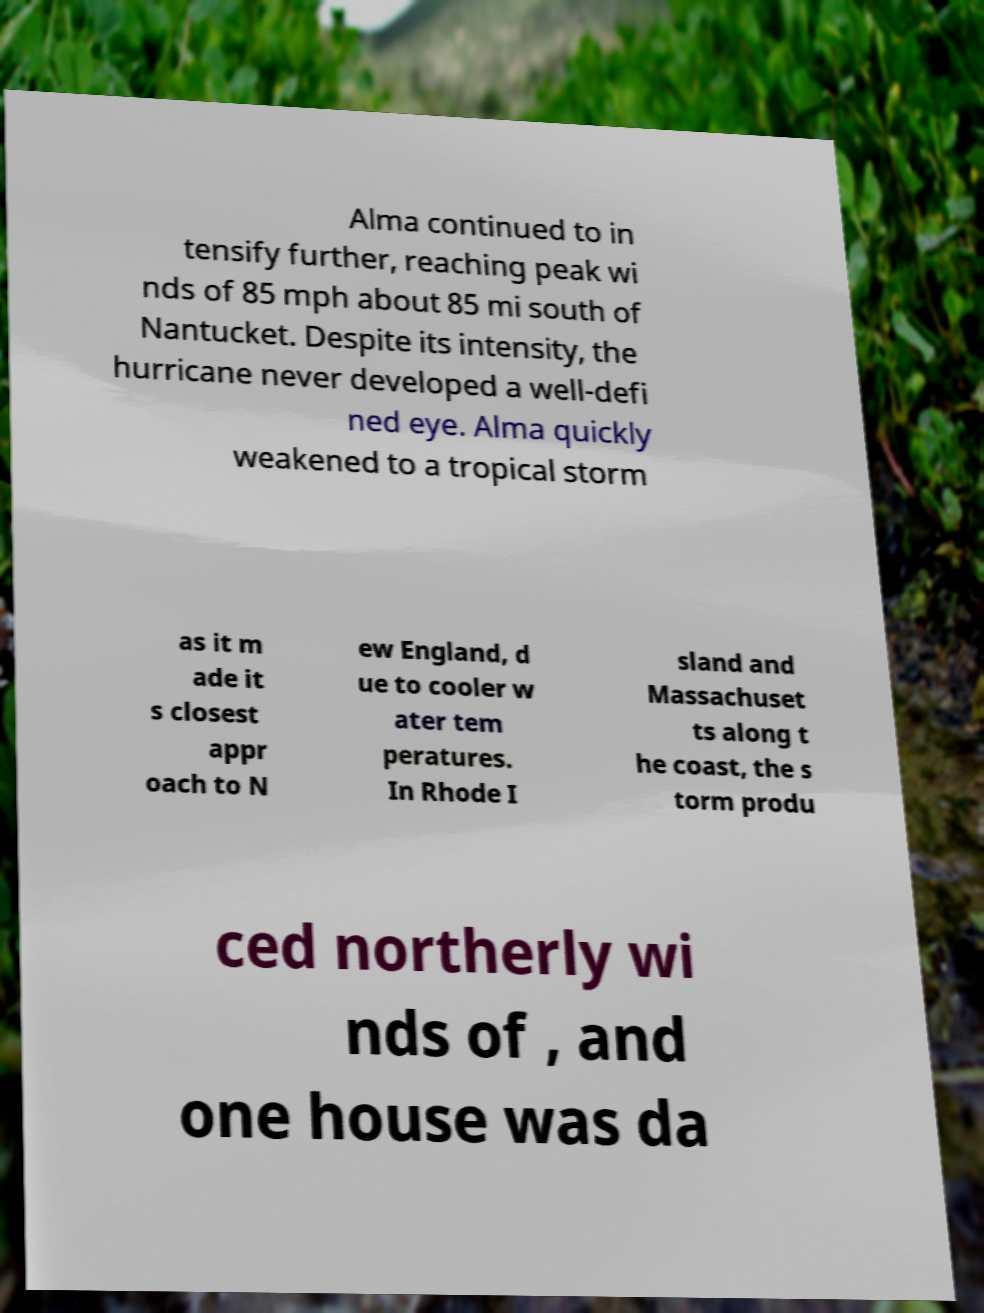Please read and relay the text visible in this image. What does it say? Alma continued to in tensify further, reaching peak wi nds of 85 mph about 85 mi south of Nantucket. Despite its intensity, the hurricane never developed a well-defi ned eye. Alma quickly weakened to a tropical storm as it m ade it s closest appr oach to N ew England, d ue to cooler w ater tem peratures. In Rhode I sland and Massachuset ts along t he coast, the s torm produ ced northerly wi nds of , and one house was da 